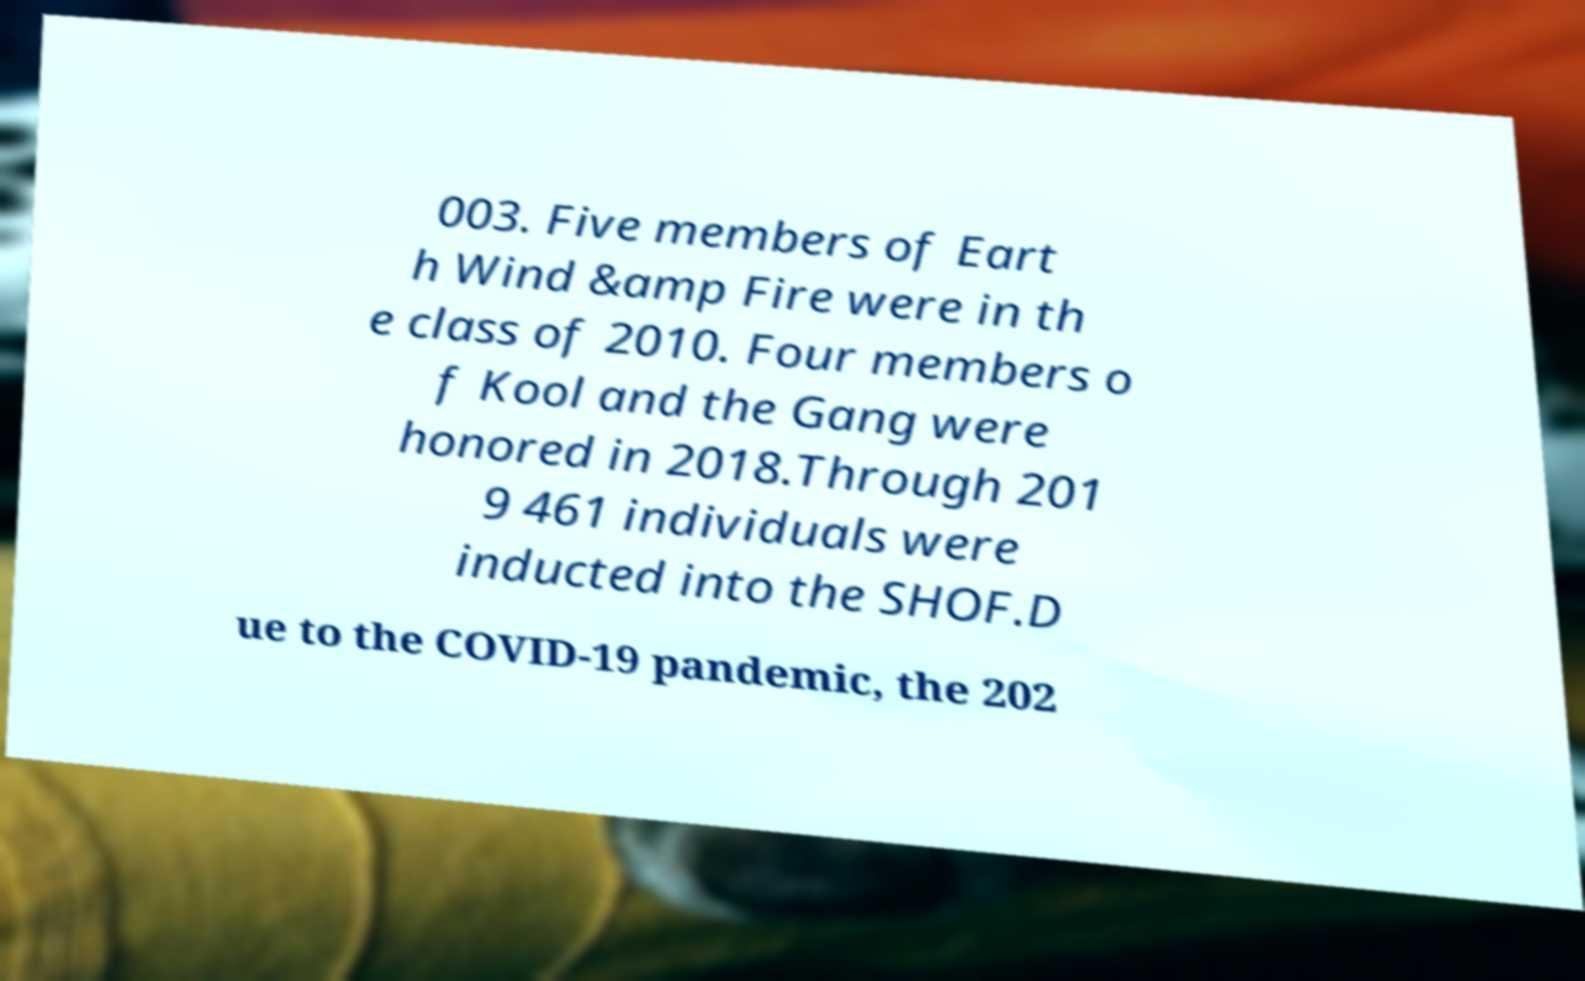Could you extract and type out the text from this image? 003. Five members of Eart h Wind &amp Fire were in th e class of 2010. Four members o f Kool and the Gang were honored in 2018.Through 201 9 461 individuals were inducted into the SHOF.D ue to the COVID-19 pandemic, the 202 